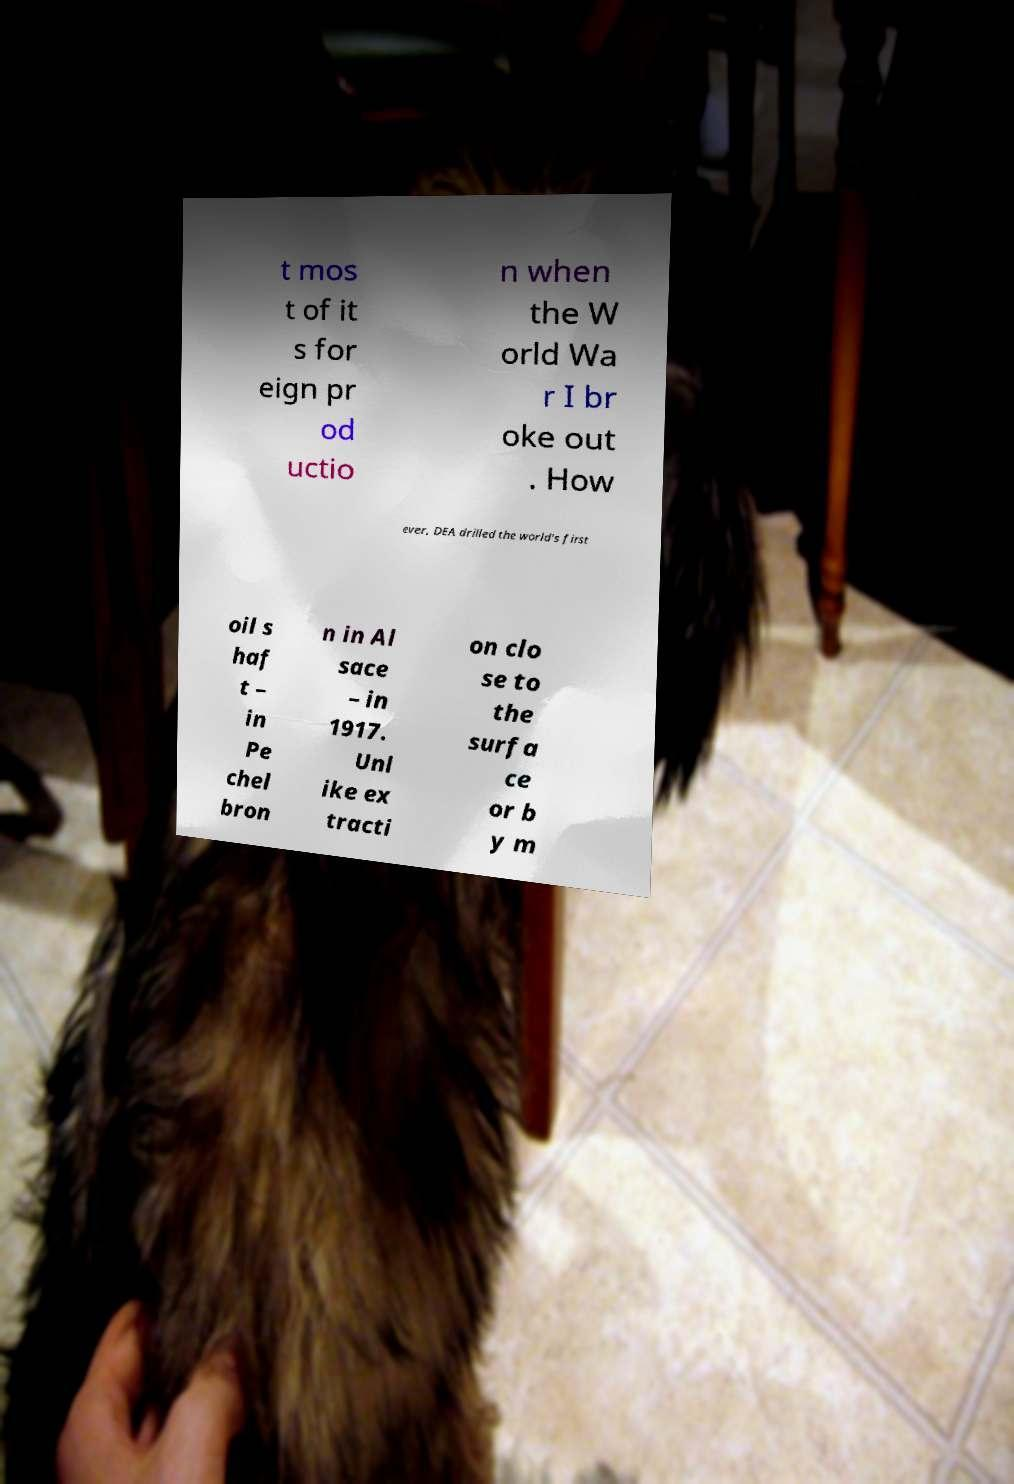Please identify and transcribe the text found in this image. t mos t of it s for eign pr od uctio n when the W orld Wa r I br oke out . How ever, DEA drilled the world's first oil s haf t – in Pe chel bron n in Al sace – in 1917. Unl ike ex tracti on clo se to the surfa ce or b y m 